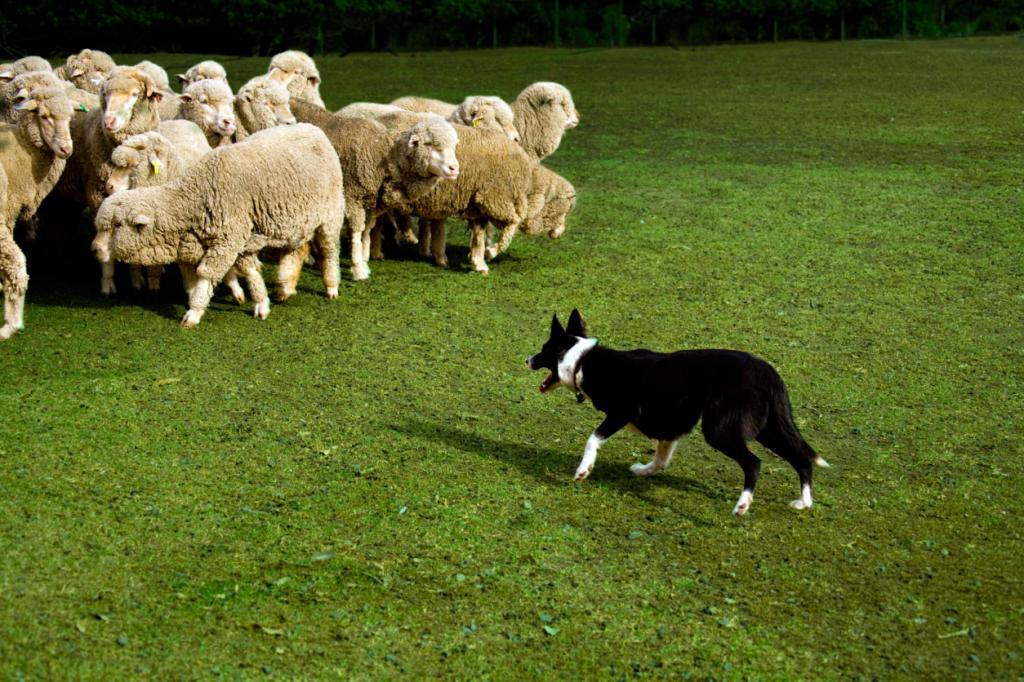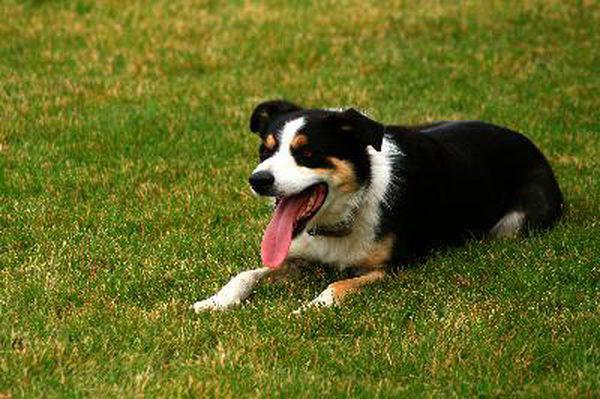The first image is the image on the left, the second image is the image on the right. For the images displayed, is the sentence "The dog is facing the animals in one of the pictures." factually correct? Answer yes or no. Yes. The first image is the image on the left, the second image is the image on the right. Evaluate the accuracy of this statement regarding the images: "An image shows a sheepdog with 3 sheep.". Is it true? Answer yes or no. No. 